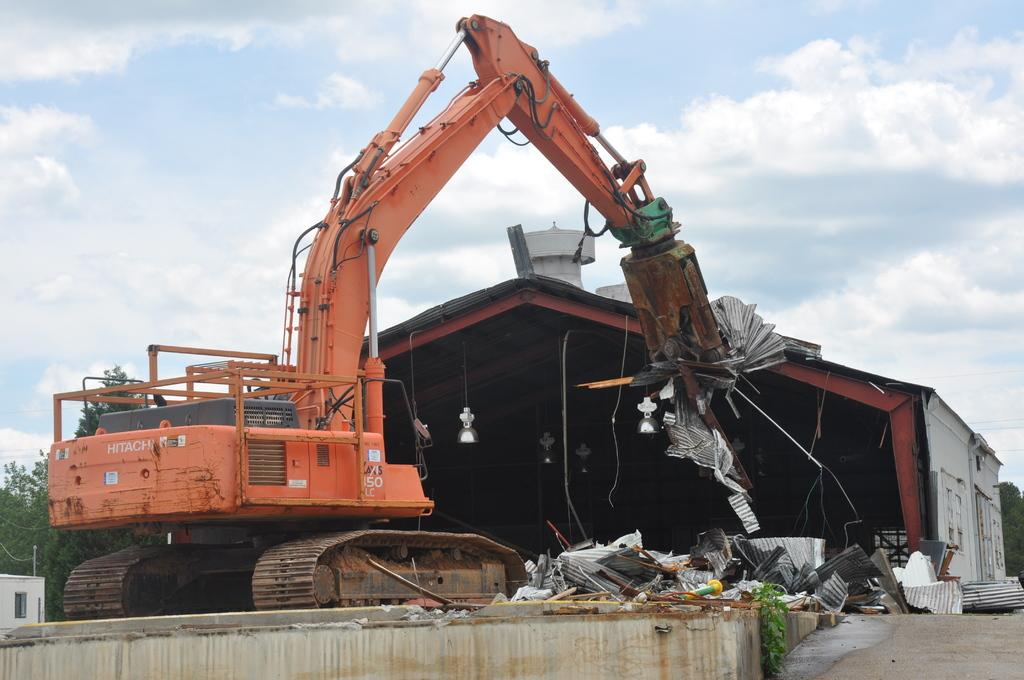What type of structure is present in the image? There is a shed in the image. What is located in front of the shed? There is a vehicle in front of the shed. What type of curve can be seen on the roof of the shed in the image? There is no curve visible on the roof of the shed in the image. 